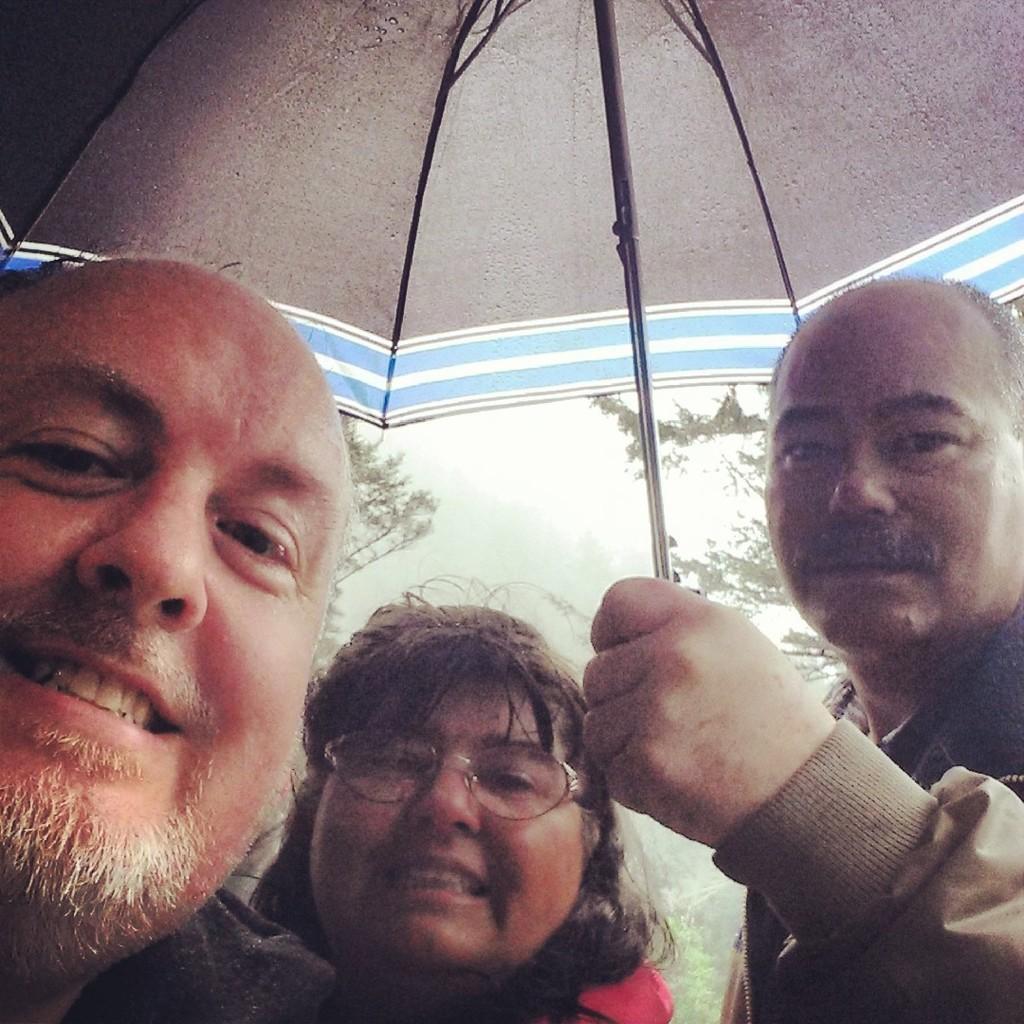In one or two sentences, can you explain what this image depicts? In the image there are three people taking a photo and the third person is holding an umbrella, behind them there are few trees. 